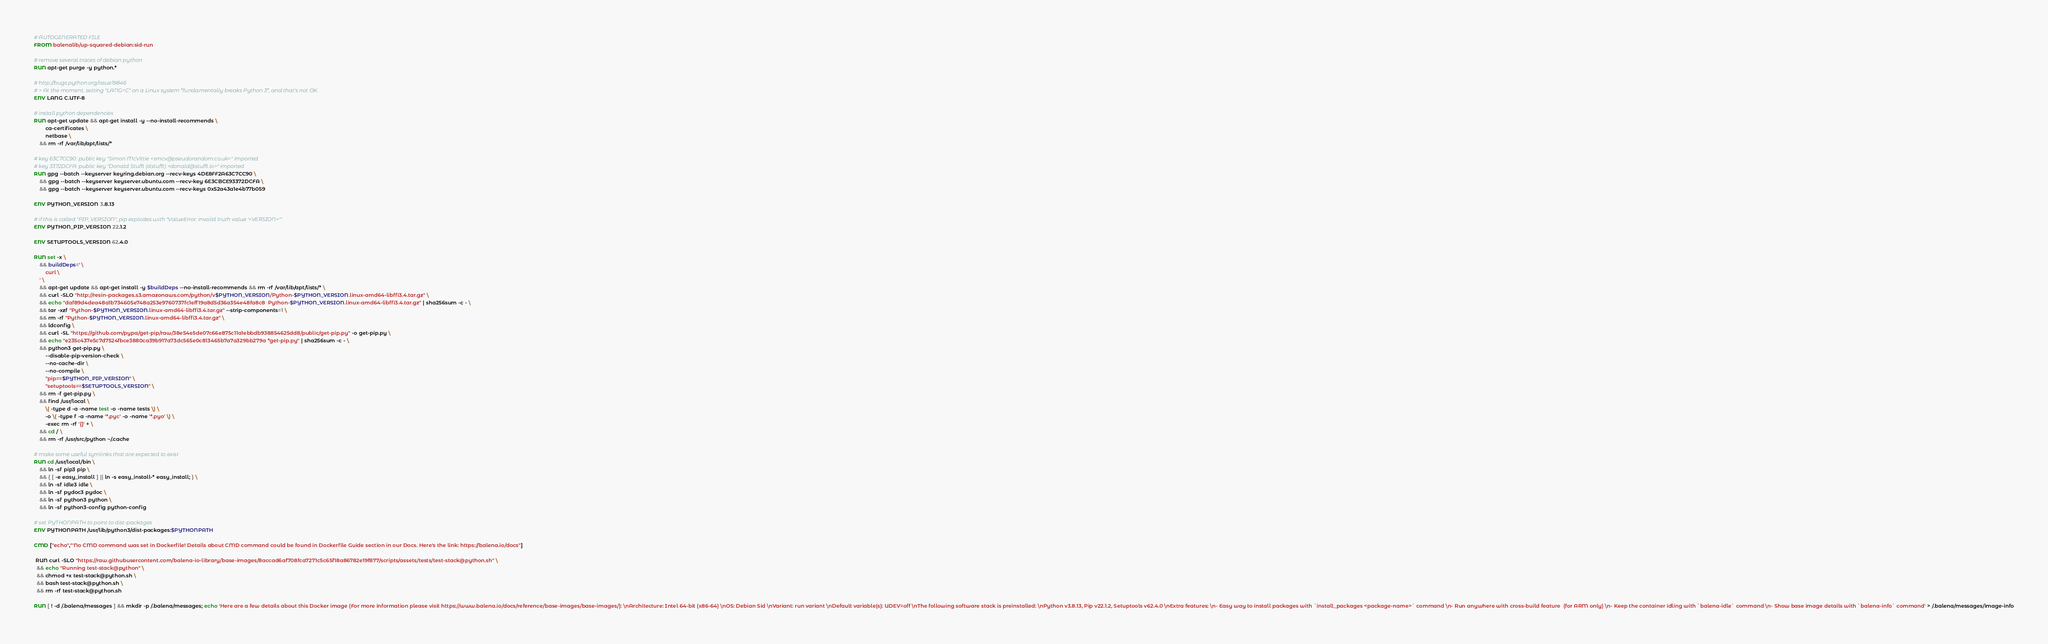<code> <loc_0><loc_0><loc_500><loc_500><_Dockerfile_># AUTOGENERATED FILE
FROM balenalib/up-squared-debian:sid-run

# remove several traces of debian python
RUN apt-get purge -y python.*

# http://bugs.python.org/issue19846
# > At the moment, setting "LANG=C" on a Linux system *fundamentally breaks Python 3*, and that's not OK.
ENV LANG C.UTF-8

# install python dependencies
RUN apt-get update && apt-get install -y --no-install-recommends \
		ca-certificates \
		netbase \
	&& rm -rf /var/lib/apt/lists/*

# key 63C7CC90: public key "Simon McVittie <smcv@pseudorandom.co.uk>" imported
# key 3372DCFA: public key "Donald Stufft (dstufft) <donald@stufft.io>" imported
RUN gpg --batch --keyserver keyring.debian.org --recv-keys 4DE8FF2A63C7CC90 \
	&& gpg --batch --keyserver keyserver.ubuntu.com --recv-key 6E3CBCE93372DCFA \
	&& gpg --batch --keyserver keyserver.ubuntu.com --recv-keys 0x52a43a1e4b77b059

ENV PYTHON_VERSION 3.8.13

# if this is called "PIP_VERSION", pip explodes with "ValueError: invalid truth value '<VERSION>'"
ENV PYTHON_PIP_VERSION 22.1.2

ENV SETUPTOOLS_VERSION 62.4.0

RUN set -x \
	&& buildDeps=' \
		curl \
	' \
	&& apt-get update && apt-get install -y $buildDeps --no-install-recommends && rm -rf /var/lib/apt/lists/* \
	&& curl -SLO "http://resin-packages.s3.amazonaws.com/python/v$PYTHON_VERSION/Python-$PYTHON_VERSION.linux-amd64-libffi3.4.tar.gz" \
	&& echo "daf89d4dea48a1b734605e748a253e9760737fc1eff19a8d5d36a354e48fa8c8  Python-$PYTHON_VERSION.linux-amd64-libffi3.4.tar.gz" | sha256sum -c - \
	&& tar -xzf "Python-$PYTHON_VERSION.linux-amd64-libffi3.4.tar.gz" --strip-components=1 \
	&& rm -rf "Python-$PYTHON_VERSION.linux-amd64-libffi3.4.tar.gz" \
	&& ldconfig \
	&& curl -SL "https://github.com/pypa/get-pip/raw/38e54e5de07c66e875c11a1ebbdb938854625dd8/public/get-pip.py" -o get-pip.py \
    && echo "e235c437e5c7d7524fbce3880ca39b917a73dc565e0c813465b7a7a329bb279a *get-pip.py" | sha256sum -c - \
    && python3 get-pip.py \
        --disable-pip-version-check \
        --no-cache-dir \
        --no-compile \
        "pip==$PYTHON_PIP_VERSION" \
        "setuptools==$SETUPTOOLS_VERSION" \
	&& rm -f get-pip.py \
	&& find /usr/local \
		\( -type d -a -name test -o -name tests \) \
		-o \( -type f -a -name '*.pyc' -o -name '*.pyo' \) \
		-exec rm -rf '{}' + \
	&& cd / \
	&& rm -rf /usr/src/python ~/.cache

# make some useful symlinks that are expected to exist
RUN cd /usr/local/bin \
	&& ln -sf pip3 pip \
	&& { [ -e easy_install ] || ln -s easy_install-* easy_install; } \
	&& ln -sf idle3 idle \
	&& ln -sf pydoc3 pydoc \
	&& ln -sf python3 python \
	&& ln -sf python3-config python-config

# set PYTHONPATH to point to dist-packages
ENV PYTHONPATH /usr/lib/python3/dist-packages:$PYTHONPATH

CMD ["echo","'No CMD command was set in Dockerfile! Details about CMD command could be found in Dockerfile Guide section in our Docs. Here's the link: https://balena.io/docs"]

 RUN curl -SLO "https://raw.githubusercontent.com/balena-io-library/base-images/8accad6af708fca7271c5c65f18a86782e19f877/scripts/assets/tests/test-stack@python.sh" \
  && echo "Running test-stack@python" \
  && chmod +x test-stack@python.sh \
  && bash test-stack@python.sh \
  && rm -rf test-stack@python.sh 

RUN [ ! -d /.balena/messages ] && mkdir -p /.balena/messages; echo 'Here are a few details about this Docker image (For more information please visit https://www.balena.io/docs/reference/base-images/base-images/): \nArchitecture: Intel 64-bit (x86-64) \nOS: Debian Sid \nVariant: run variant \nDefault variable(s): UDEV=off \nThe following software stack is preinstalled: \nPython v3.8.13, Pip v22.1.2, Setuptools v62.4.0 \nExtra features: \n- Easy way to install packages with `install_packages <package-name>` command \n- Run anywhere with cross-build feature  (for ARM only) \n- Keep the container idling with `balena-idle` command \n- Show base image details with `balena-info` command' > /.balena/messages/image-info</code> 